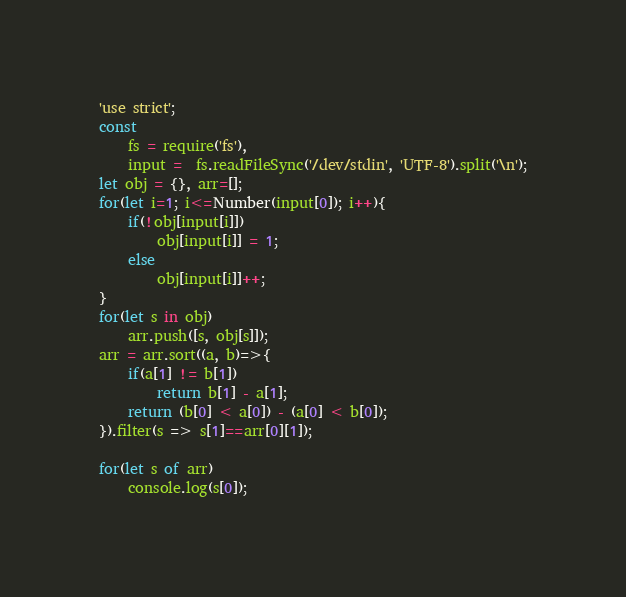Convert code to text. <code><loc_0><loc_0><loc_500><loc_500><_JavaScript_>'use strict';
const 
    fs = require('fs'),
    input =  fs.readFileSync('/dev/stdin', 'UTF-8').split('\n');
let obj = {}, arr=[];
for(let i=1; i<=Number(input[0]); i++){
    if(!obj[input[i]])
        obj[input[i]] = 1;
    else
        obj[input[i]]++;
}
for(let s in obj)
    arr.push([s, obj[s]]);
arr = arr.sort((a, b)=>{
    if(a[1] != b[1])
        return b[1] - a[1];
    return (b[0] < a[0]) - (a[0] < b[0]);
}).filter(s => s[1]==arr[0][1]);

for(let s of arr)
    console.log(s[0]);</code> 